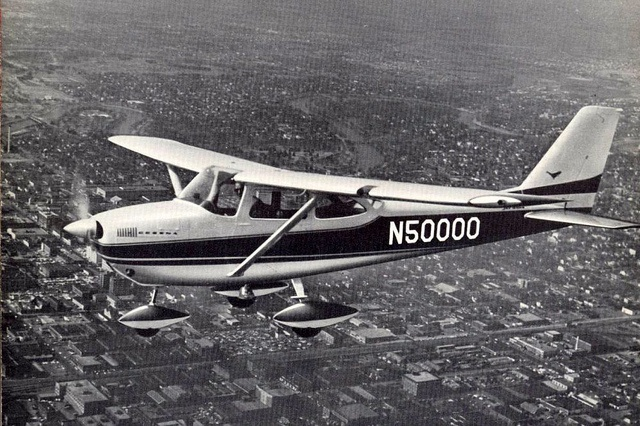Describe the objects in this image and their specific colors. I can see a airplane in gray, black, lightgray, and darkgray tones in this image. 